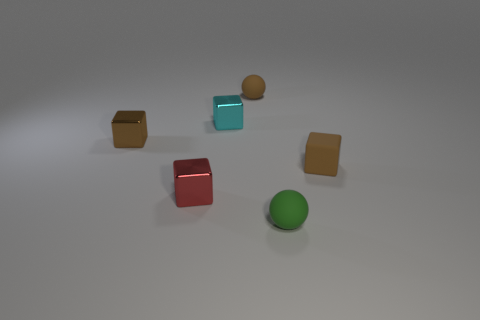Subtract all brown metal blocks. How many blocks are left? 3 Subtract 2 cubes. How many cubes are left? 2 Subtract all purple spheres. How many brown cubes are left? 2 Subtract all cyan cubes. How many cubes are left? 3 Add 4 tiny brown shiny spheres. How many objects exist? 10 Subtract all yellow blocks. Subtract all red spheres. How many blocks are left? 4 Subtract all balls. How many objects are left? 4 Subtract all green matte spheres. Subtract all tiny matte blocks. How many objects are left? 4 Add 1 small green balls. How many small green balls are left? 2 Add 6 tiny blue matte objects. How many tiny blue matte objects exist? 6 